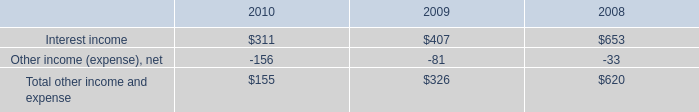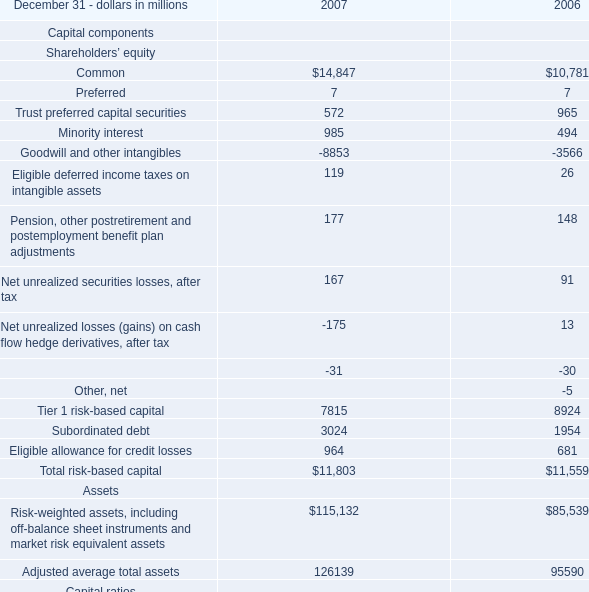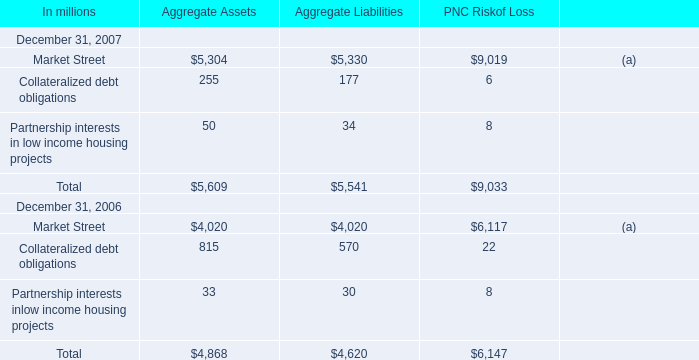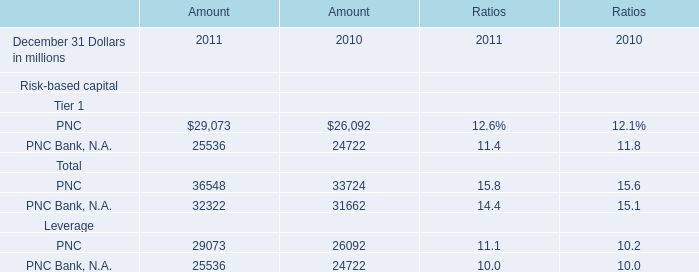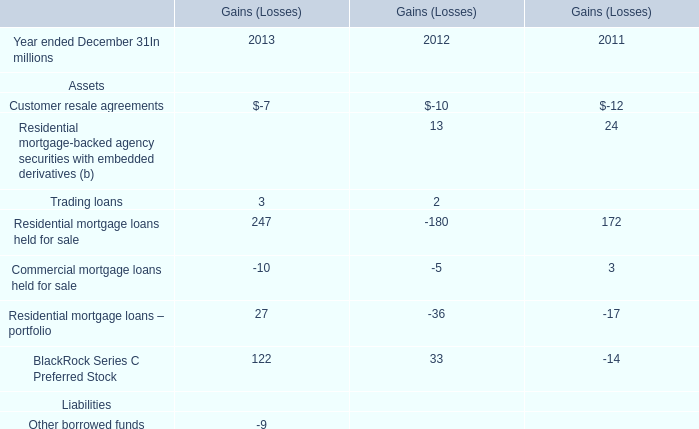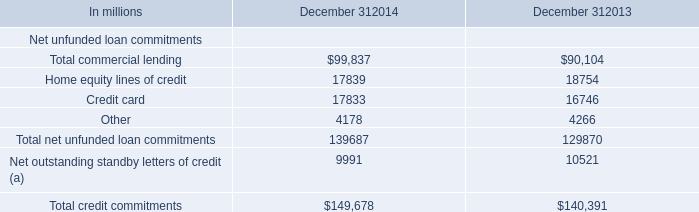What is the proportion of all Aggregate Liabilities that are greater than 100 to the total amount of Aggregate Liabilities, in 2007? 
Computations: ((5330 + 177) / 5541)
Answer: 0.99386. 